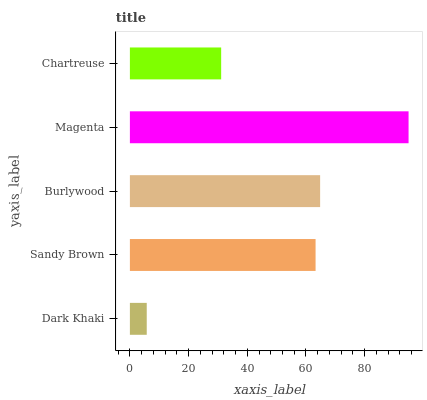Is Dark Khaki the minimum?
Answer yes or no. Yes. Is Magenta the maximum?
Answer yes or no. Yes. Is Sandy Brown the minimum?
Answer yes or no. No. Is Sandy Brown the maximum?
Answer yes or no. No. Is Sandy Brown greater than Dark Khaki?
Answer yes or no. Yes. Is Dark Khaki less than Sandy Brown?
Answer yes or no. Yes. Is Dark Khaki greater than Sandy Brown?
Answer yes or no. No. Is Sandy Brown less than Dark Khaki?
Answer yes or no. No. Is Sandy Brown the high median?
Answer yes or no. Yes. Is Sandy Brown the low median?
Answer yes or no. Yes. Is Dark Khaki the high median?
Answer yes or no. No. Is Burlywood the low median?
Answer yes or no. No. 